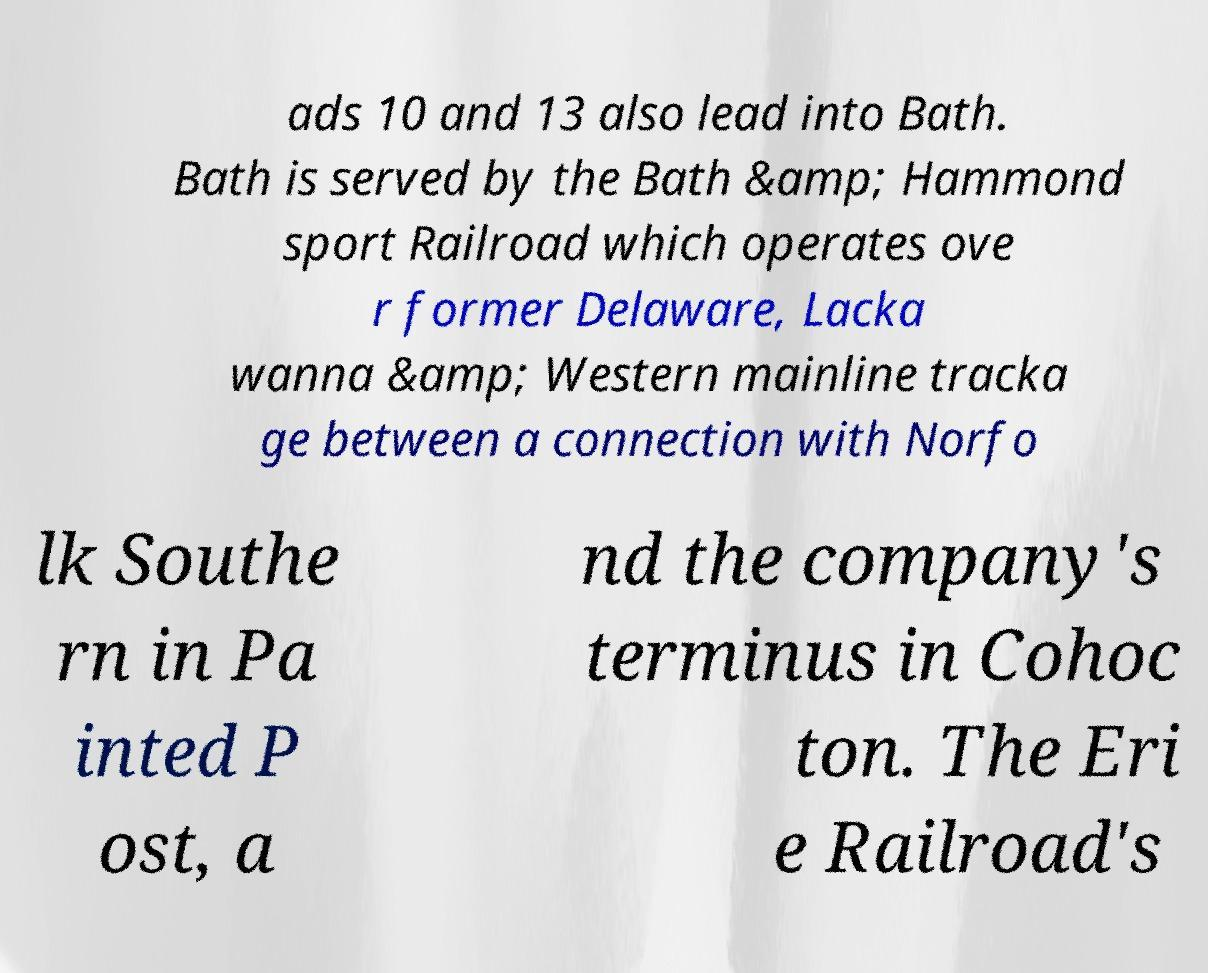Can you accurately transcribe the text from the provided image for me? ads 10 and 13 also lead into Bath. Bath is served by the Bath &amp; Hammond sport Railroad which operates ove r former Delaware, Lacka wanna &amp; Western mainline tracka ge between a connection with Norfo lk Southe rn in Pa inted P ost, a nd the company's terminus in Cohoc ton. The Eri e Railroad's 